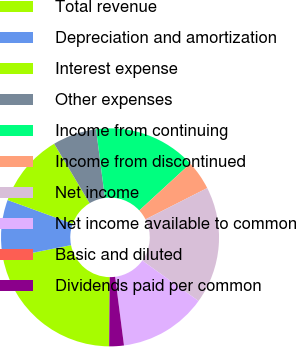Convert chart. <chart><loc_0><loc_0><loc_500><loc_500><pie_chart><fcel>Total revenue<fcel>Depreciation and amortization<fcel>Interest expense<fcel>Other expenses<fcel>Income from continuing<fcel>Income from discontinued<fcel>Net income<fcel>Net income available to common<fcel>Basic and diluted<fcel>Dividends paid per common<nl><fcel>21.74%<fcel>8.7%<fcel>10.87%<fcel>6.52%<fcel>15.22%<fcel>4.35%<fcel>17.39%<fcel>13.04%<fcel>0.0%<fcel>2.17%<nl></chart> 